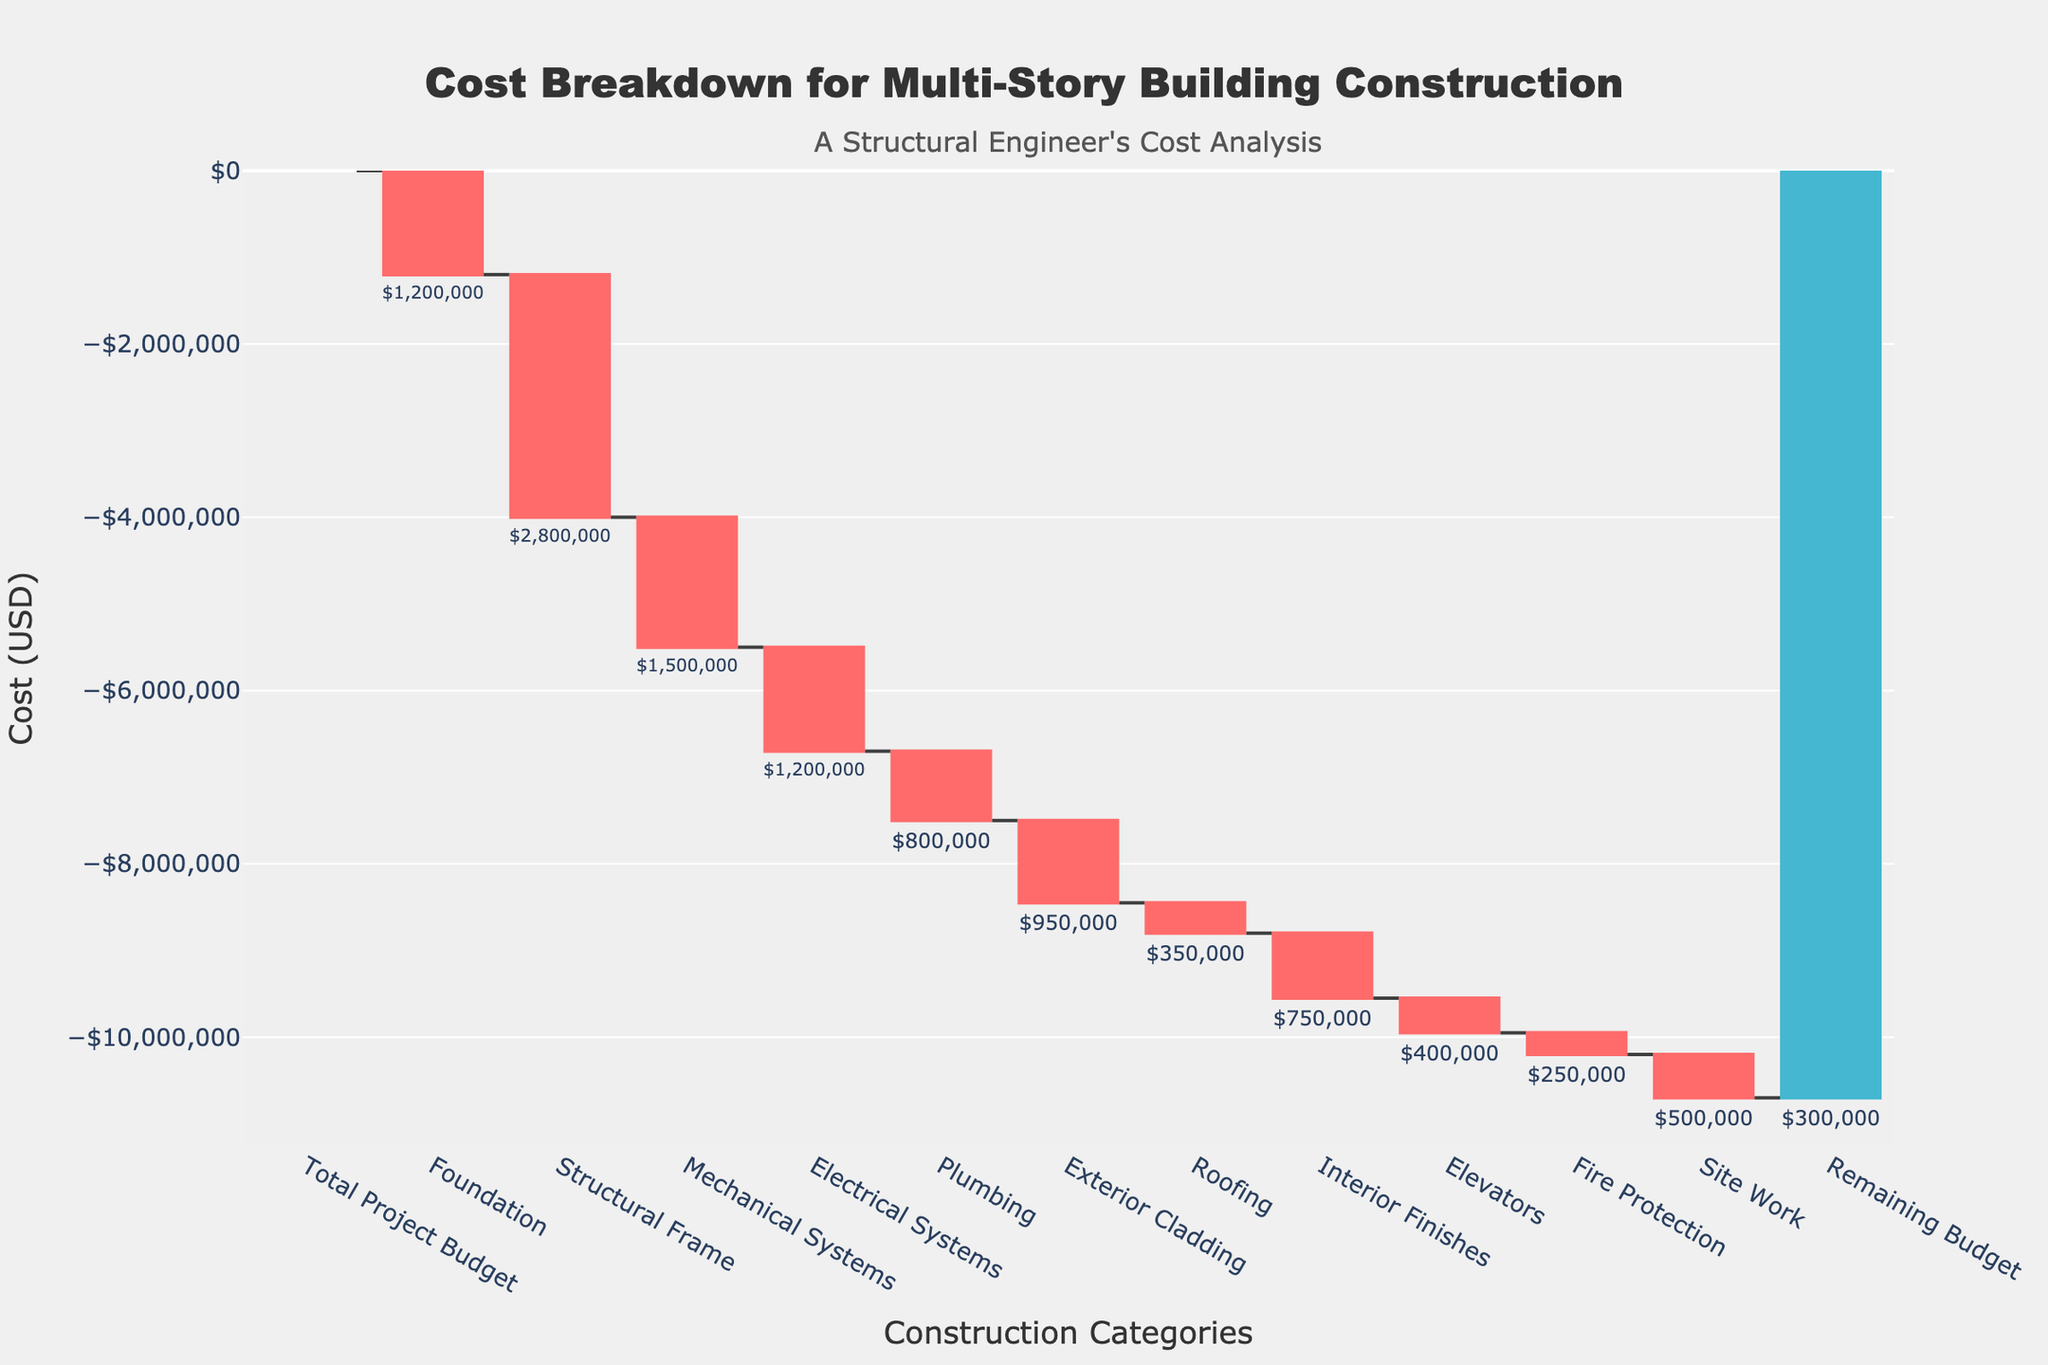What is the title of the chart? The title is located at the top of the chart. It reads "Cost Breakdown for Multi-Story Building Construction."
Answer: Cost Breakdown for Multi-Story Building Construction How much is allocated for the Foundation? The value associated with the Foundation is noted on the vertical axis as well as next to the bar for Foundation in the chart. It is -$1,200,000.
Answer: $1,200,000 What is the total cost allocated for the Structural Frame and Plumbing combined? You add the value for the Structural Frame, which is -$2,800,000, to the value for Plumbing, which is -$800,000. This results in a total of -$3,600,000.
Answer: $3,600,000 Which category has the second highest cost allocation? By examining the height of the bars and associated values, the first highest cost is the Structural Frame at -$2,800,000 and the second highest is the Mechanical Systems at -$1,500,000.
Answer: Mechanical Systems What is the total of all costs excluding the Remaining Budget? Sum up all the costs: (-$1,200,000) + (-$2,800,000) + (-$1,500,000) + (-$1,200,000) + (-$800,000) + (-$950,000) + (-$350,000) + (-$750,000) + (-$400,000) + (-$250,000) + (-$500,000) = -$10,700,000. Exclude the Remaining Budget of $300,000, total is -$10,700,000.
Answer: $10,700,000 How much more is spent on Electrical Systems compared to Fire Protection? The cost for Electrical Systems is -$1,200,000 and for Fire Protection is -$250,000. The difference is -$1,200,000 - (-$250,000) = -$950,000.
Answer: $950,000 What is the net change from Total Project Budget to the Remaining Budget? Total Project Budget is $10,000,000. The Remaining Budget is $300,000. => Net change = $10,000,000 - $300,000 = $9,700,000.
Answer: $9,700,000 Which category has the smallest cost allocation? By looking at the smallest bar on the chart, the smallest cost allocation is for Fire Protection at -$250,000.
Answer: Fire Protection What percentage of the total project budget does the cost for Roofing represent? The cost for Roofing is -$350,000. The total project budget is $10,000,000. => Percentage = ($350,000 / $10,000,000) * 100 = 3.5%.
Answer: 3.5% 